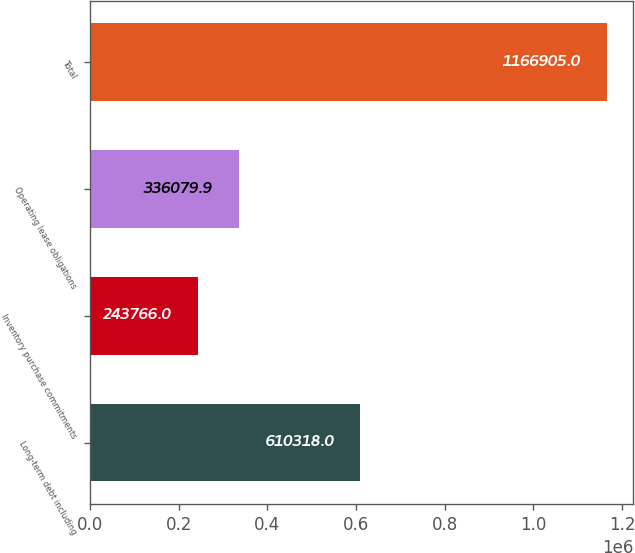Convert chart. <chart><loc_0><loc_0><loc_500><loc_500><bar_chart><fcel>Long-term debt including<fcel>Inventory purchase commitments<fcel>Operating lease obligations<fcel>Total<nl><fcel>610318<fcel>243766<fcel>336080<fcel>1.1669e+06<nl></chart> 